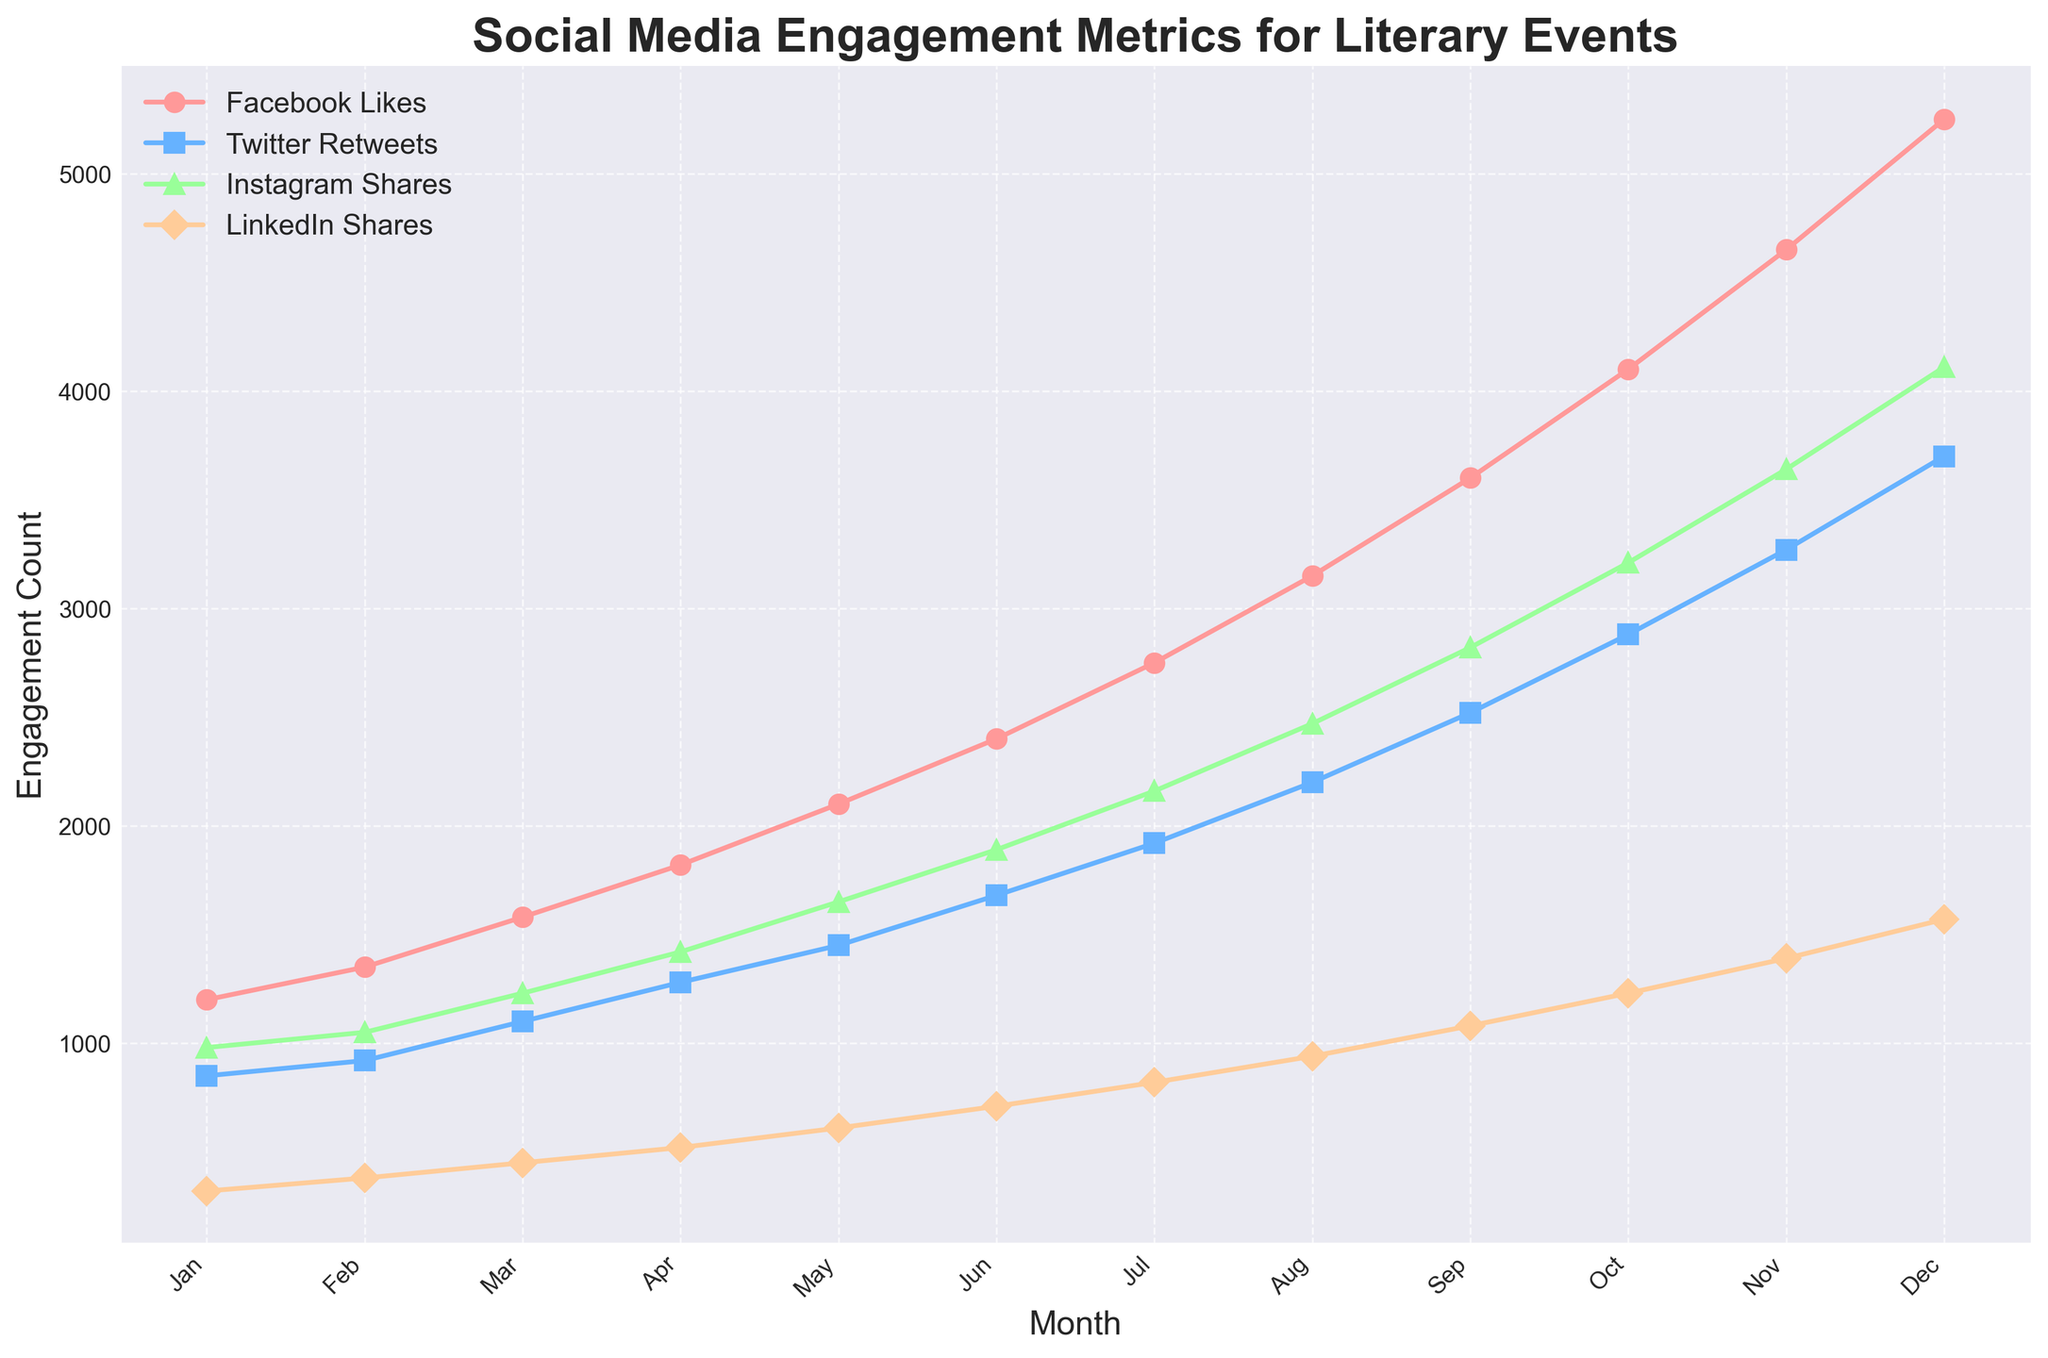Which month recorded the highest number of Twitter Retweets? The line for Twitter Retweets reaches its peak at the highest point in December, indicating the maximum number of retweets for that month.
Answer: December How does the number of Facebook Likes in June compare to that in November? In June, Facebook Likes are 2400, and in November, they are 4650. Comparing these values, November has significantly more likes.
Answer: November has more What's the difference in Instagram Shares between September and October? The number of Instagram Shares in September is 2820, while in October it is 3210. The difference is calculated by subtracting the two values: 3210 - 2820 = 390.
Answer: 390 Which engagement metric experienced the most growth from January to December? By looking at the trend lines for each metric from January to December, Facebook Likes increased from 1200 to 5250, which is the largest increase among the given metrics.
Answer: Facebook Likes What is the sum of LinkedIn Shares for the first quarter (Jan-Mar)? In the first quarter, LinkedIn Shares are 320 (Jan), 380 (Feb), and 450 (Mar). Adding these together: 320 + 380 + 450 = 1150.
Answer: 1150 Which metric has a steeper climb between July and August, Facebook Likes or Twitter Retweets? The slope of the changes in Facebook Likes from July (2750) to August (3150) is 3150 - 2750 = 400, and for Twitter Retweets from July (1920) to August (2200) is 2200 - 1920 = 280. Facebook Likes have a steeper climb.
Answer: Facebook Likes Between which consecutive months does Instagram Shares show the smallest increase? Looking at the line for Instagram Shares, April to May shows an increase from 1420 to 1650, which is 1650 - 1420 = 230. This increase appears smaller than others when inspected visually.
Answer: April to May How many more LinkedIn Shares were recorded in December compared to April? LinkedIn Shares in December are 1570, and in April, they are 520. Subtracting these, 1570 - 520 = 1050.
Answer: 1050 What is the average number of Twitter Retweets for the months of Apr, May, and Jun? The values for Twitter Retweets are 1280 (April), 1450 (May), and 1680 (June). Adding these and dividing by 3: (1280 + 1450 + 1680) / 3 = 4410 / 3 = 1470.
Answer: 1470 